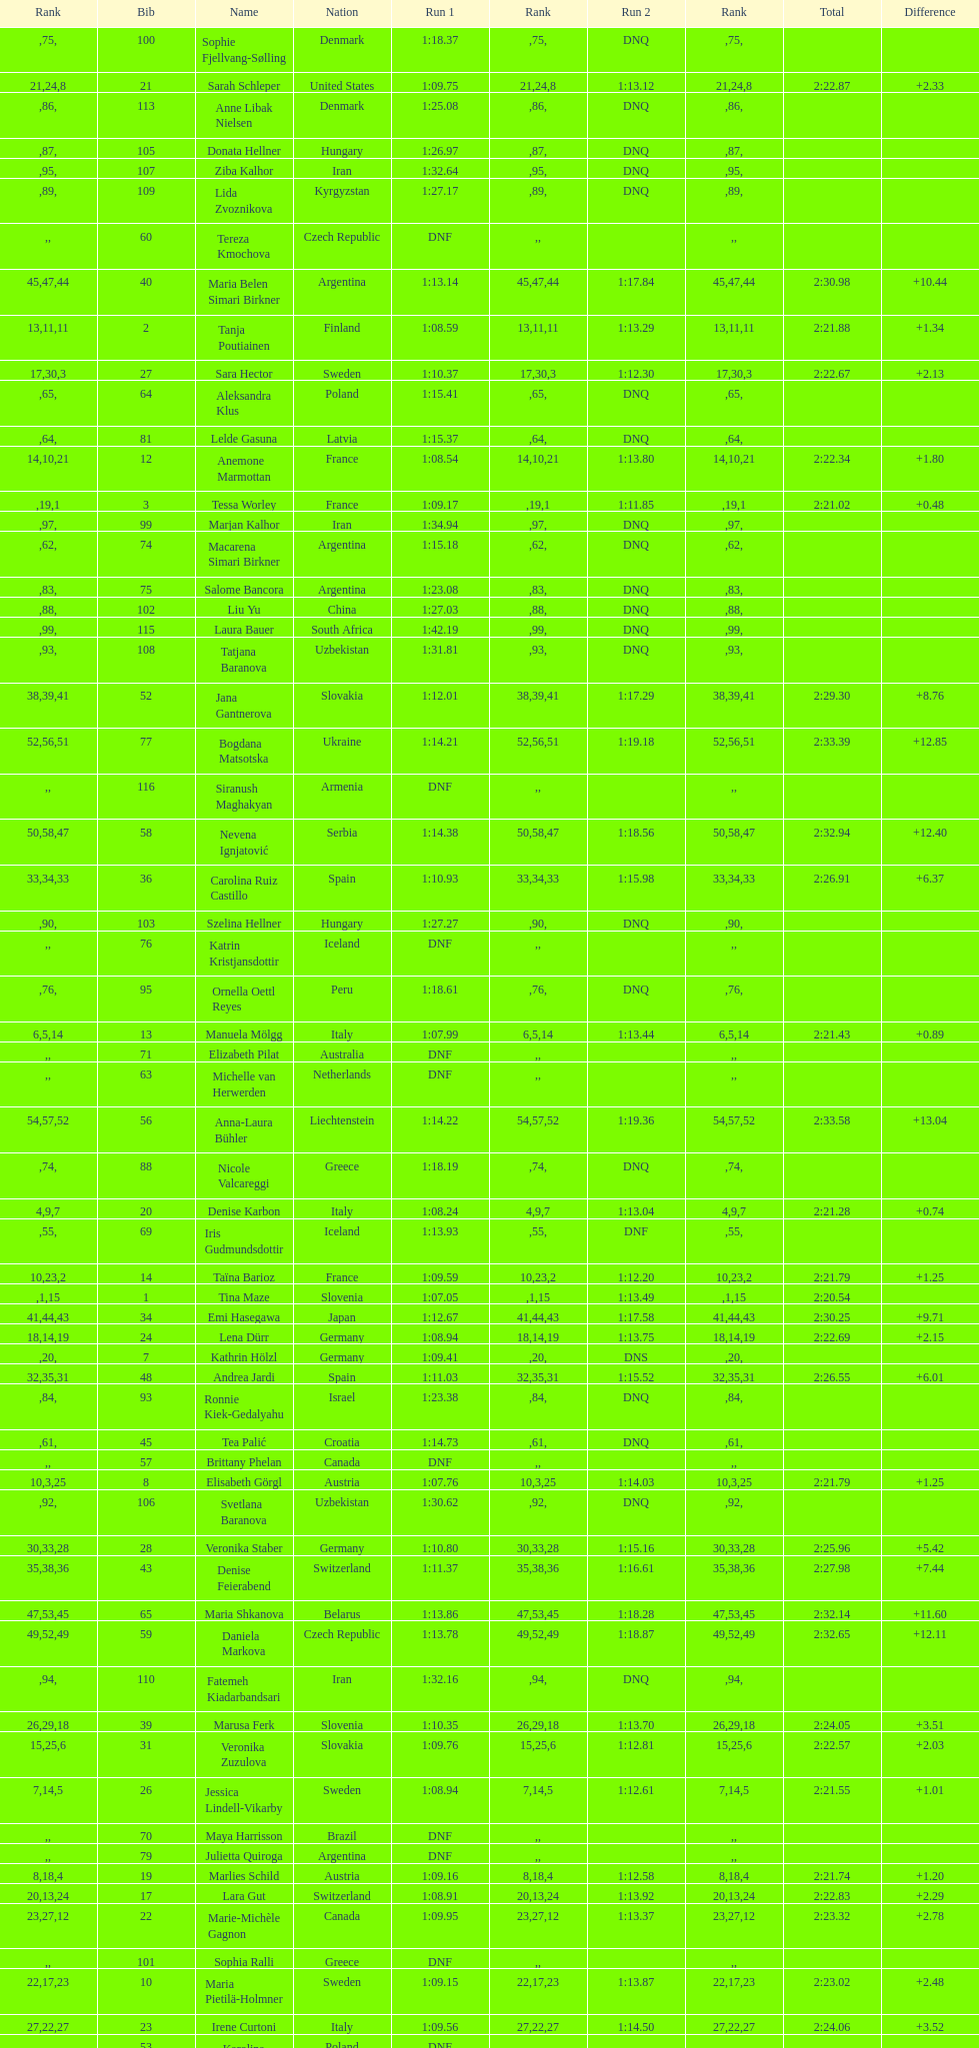How many italians finished in the top ten? 3. 